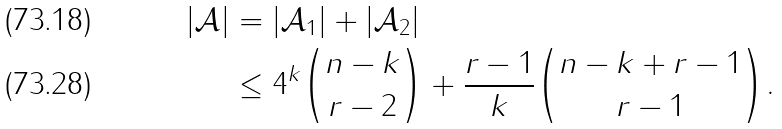Convert formula to latex. <formula><loc_0><loc_0><loc_500><loc_500>| \mathcal { A } | & = | \mathcal { A } _ { 1 } | + | \mathcal { A } _ { 2 } | \\ & \leq 4 ^ { k } \binom { n - k } { r - 2 } + \frac { r - 1 } { k } \binom { n - k + r - 1 } { r - 1 } .</formula> 